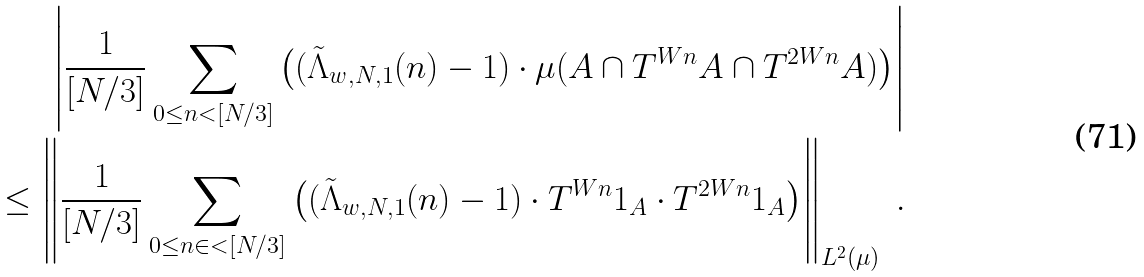Convert formula to latex. <formula><loc_0><loc_0><loc_500><loc_500>\left | \frac { 1 } { [ N / 3 ] } \sum _ { 0 \leq n < [ N / 3 ] } \left ( ( \tilde { \Lambda } _ { w , N , 1 } ( n ) - 1 ) \cdot \mu ( A \cap T ^ { W n } A \cap T ^ { 2 W n } A ) \right ) \right | \\ \leq \left \| \frac { 1 } { [ N / 3 ] } \sum _ { 0 \leq n \in < [ N / 3 ] } \left ( ( \tilde { \Lambda } _ { w , N , 1 } ( n ) - 1 ) \cdot T ^ { W n } { 1 } _ { A } \cdot T ^ { 2 W n } { 1 } _ { A } \right ) \right \| _ { L ^ { 2 } ( \mu ) } \ .</formula> 